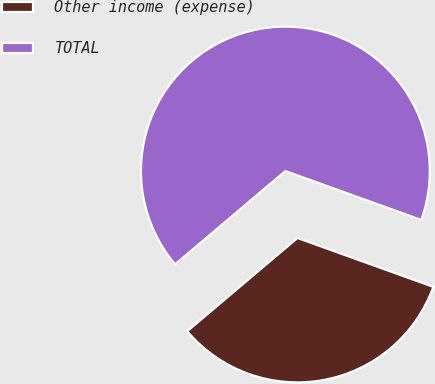Convert chart. <chart><loc_0><loc_0><loc_500><loc_500><pie_chart><fcel>Other income (expense)<fcel>TOTAL<nl><fcel>33.33%<fcel>66.67%<nl></chart> 